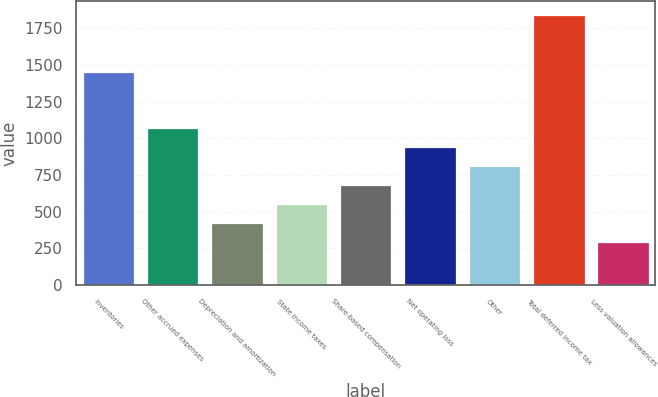Convert chart to OTSL. <chart><loc_0><loc_0><loc_500><loc_500><bar_chart><fcel>Inventories<fcel>Other accrued expenses<fcel>Depreciation and amortization<fcel>State income taxes<fcel>Share-based compensation<fcel>Net operating loss<fcel>Other<fcel>Total deferred income tax<fcel>Less valuation allowances<nl><fcel>1455.2<fcel>1067.6<fcel>421.6<fcel>550.8<fcel>680<fcel>938.4<fcel>809.2<fcel>1842.8<fcel>292.4<nl></chart> 